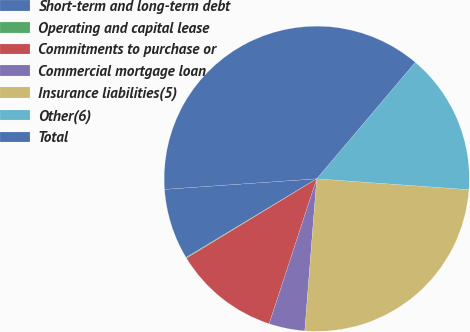Convert chart to OTSL. <chart><loc_0><loc_0><loc_500><loc_500><pie_chart><fcel>Short-term and long-term debt<fcel>Operating and capital lease<fcel>Commitments to purchase or<fcel>Commercial mortgage loan<fcel>Insurance liabilities(5)<fcel>Other(6)<fcel>Total<nl><fcel>7.52%<fcel>0.09%<fcel>11.24%<fcel>3.8%<fcel>25.11%<fcel>14.96%<fcel>37.28%<nl></chart> 